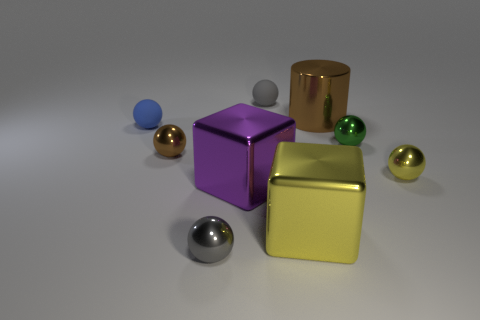What is the material of the brown thing that is the same size as the purple shiny block? The brown object that corresponds in size to the purple block appears to be made of a polished metal, potentially bronze or copper, which gives it a reflective and glossy surface similar to the purple block's sheen. 